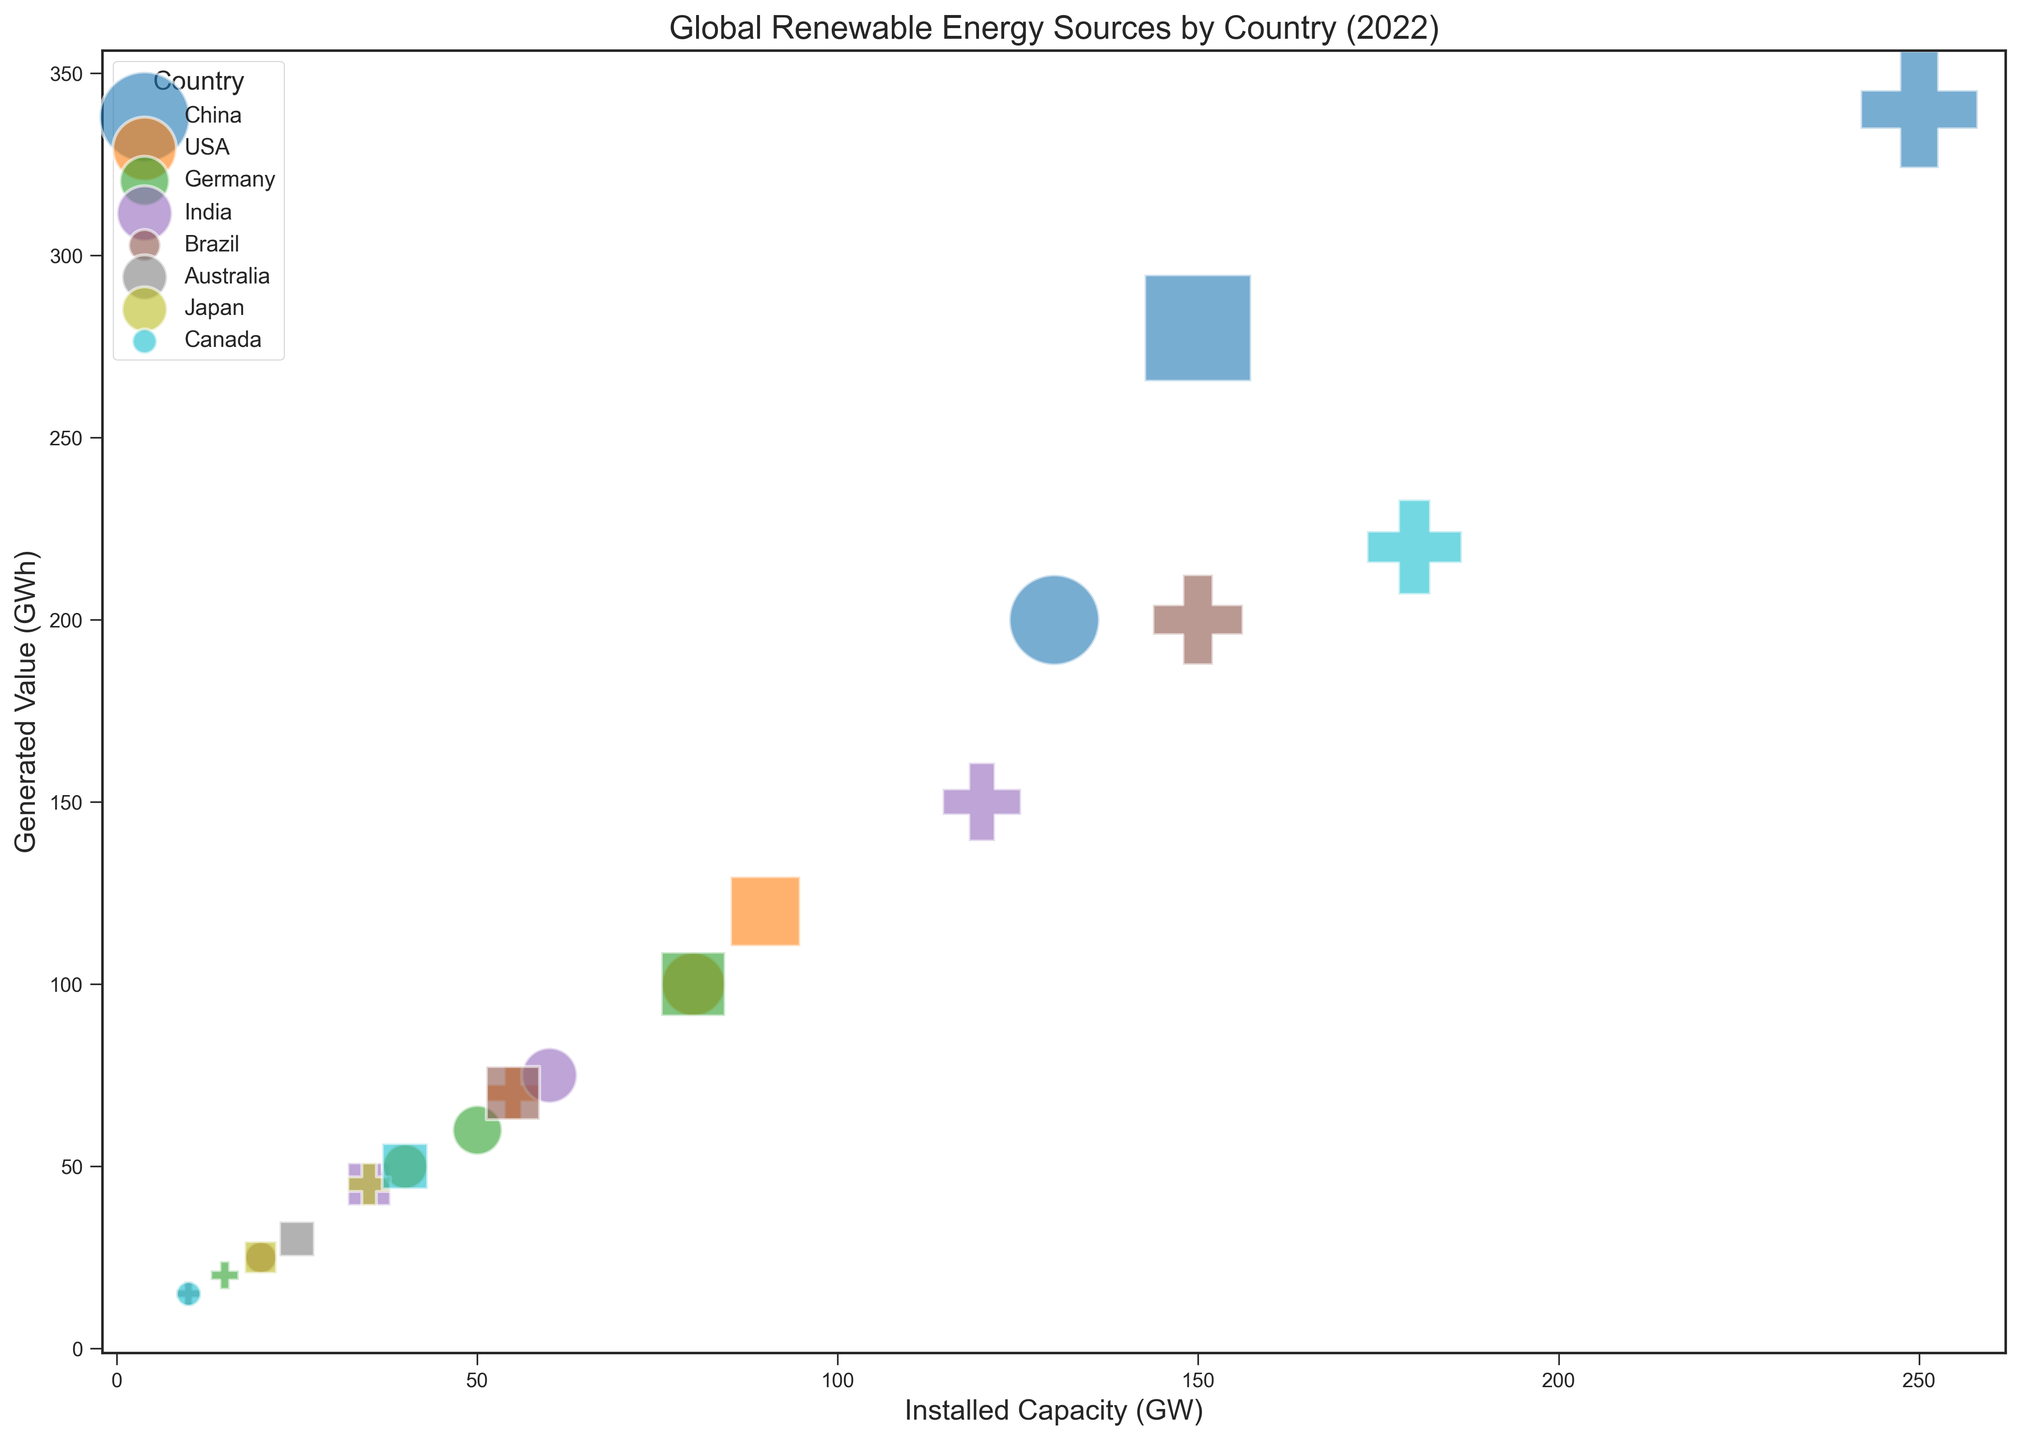What's the total generated value of wind energy across all countries combined? First, identify all the values corresponding to wind energy in the figure. Summing them up: 280 (China) + 120 (USA) + 100 (Germany) + 45 (India) + 70 (Brazil) + 30 (Australia) + 25 (Japan) + 50 (Canada) = 720 GWh
Answer: 720 GWh Which country has the highest installed capacity for hydro power? Look at the hydro power categories for each country and compare the capacity values. China has the highest hydro capacity with 250 GW.
Answer: China Compare the solar energy capacities of Germany and Japan. Which one is higher? Look at the solar energy capacities for Germany and Japan. Germany has 50 GW, while Japan has 40 GW. Therefore, Germany has a higher solar energy capacity than Japan.
Answer: Germany How does the value of solar energy generated in Brazil compare to that in India? Look at the values of solar energy generated for Brazil and India. Brazil generates 25 GWh, whereas India generates 75 GWh. Therefore, India generates more solar energy than Brazil.
Answer: India What is the average installed capacity of wind energy across USA, Germany, and Canada? Calculate the wind capacities for USA (90 GW), Germany (80 GW), and Canada (40 GW). The average is (90 + 80 + 40) / 3 = 70 GW.
Answer: 70 GW What is the total capacity of renewable energy in Australia? Sum the capacities of solar, wind, and hydro types in Australia: 40 (solar) + 25 (wind) + 10 (hydro) = 75 GW.
Answer: 75 GW Which country has the smallest bubble for hydro energy in the figure and what does this represent? Look at the size of the bubbles for hydro energy for all countries. The smallest bubble is for Australia, which means it has the lowest generated value of hydro energy, 15 GWh.
Answer: Australia, 15 GWh 